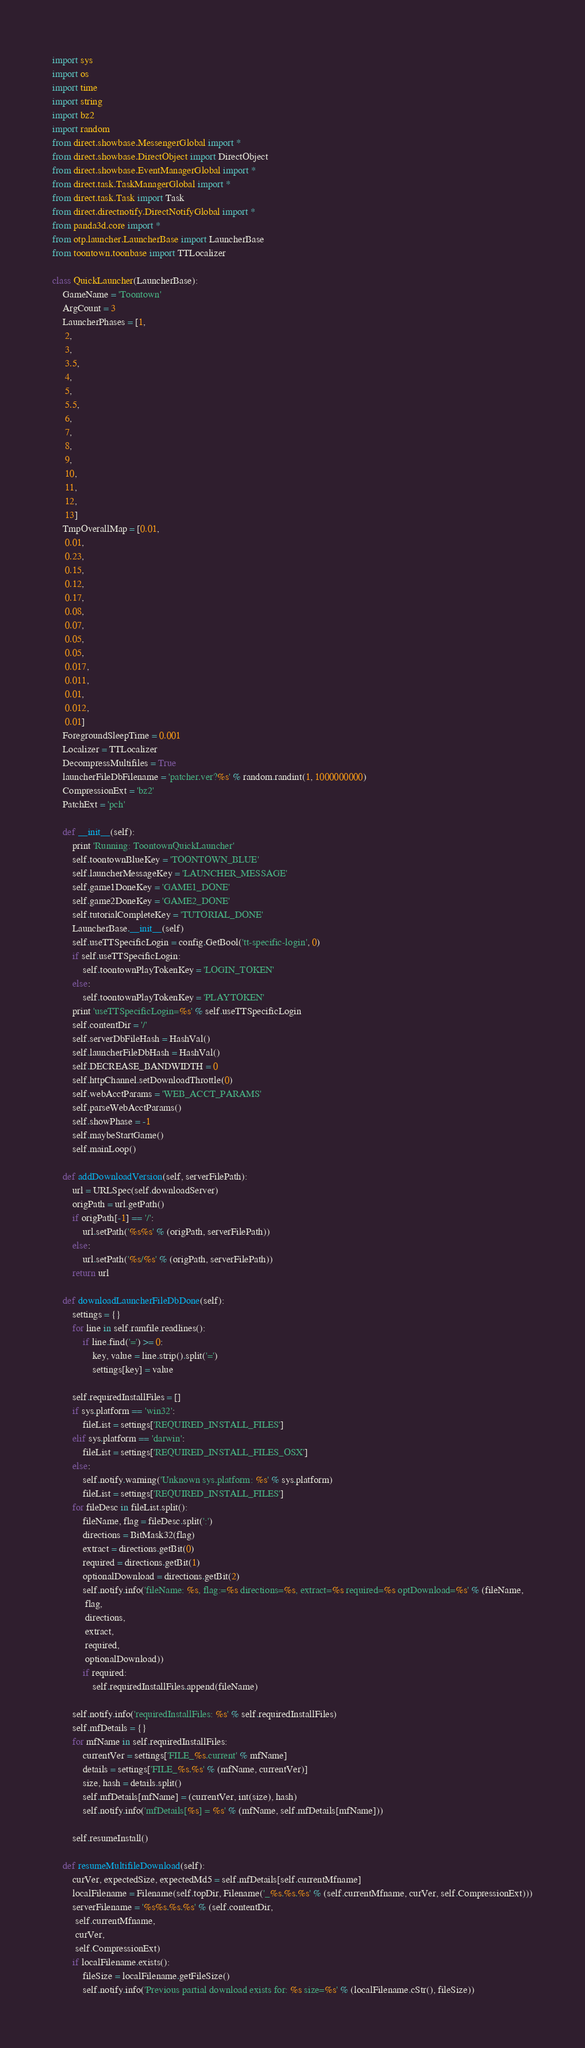Convert code to text. <code><loc_0><loc_0><loc_500><loc_500><_Python_>import sys
import os
import time
import string
import bz2
import random
from direct.showbase.MessengerGlobal import *
from direct.showbase.DirectObject import DirectObject
from direct.showbase.EventManagerGlobal import *
from direct.task.TaskManagerGlobal import *
from direct.task.Task import Task
from direct.directnotify.DirectNotifyGlobal import *
from panda3d.core import *
from otp.launcher.LauncherBase import LauncherBase
from toontown.toonbase import TTLocalizer

class QuickLauncher(LauncherBase):
    GameName = 'Toontown'
    ArgCount = 3
    LauncherPhases = [1,
     2,
     3,
     3.5,
     4,
     5,
     5.5,
     6,
     7,
     8,
     9,
     10,
     11,
     12,
     13]
    TmpOverallMap = [0.01,
     0.01,
     0.23,
     0.15,
     0.12,
     0.17,
     0.08,
     0.07,
     0.05,
     0.05,
     0.017,
     0.011,
     0.01,
     0.012,
     0.01]
    ForegroundSleepTime = 0.001
    Localizer = TTLocalizer
    DecompressMultifiles = True
    launcherFileDbFilename = 'patcher.ver?%s' % random.randint(1, 1000000000)
    CompressionExt = 'bz2'
    PatchExt = 'pch'

    def __init__(self):
        print 'Running: ToontownQuickLauncher'
        self.toontownBlueKey = 'TOONTOWN_BLUE'
        self.launcherMessageKey = 'LAUNCHER_MESSAGE'
        self.game1DoneKey = 'GAME1_DONE'
        self.game2DoneKey = 'GAME2_DONE'
        self.tutorialCompleteKey = 'TUTORIAL_DONE'
        LauncherBase.__init__(self)
        self.useTTSpecificLogin = config.GetBool('tt-specific-login', 0)
        if self.useTTSpecificLogin:
            self.toontownPlayTokenKey = 'LOGIN_TOKEN'
        else:
            self.toontownPlayTokenKey = 'PLAYTOKEN'
        print 'useTTSpecificLogin=%s' % self.useTTSpecificLogin
        self.contentDir = '/'
        self.serverDbFileHash = HashVal()
        self.launcherFileDbHash = HashVal()
        self.DECREASE_BANDWIDTH = 0
        self.httpChannel.setDownloadThrottle(0)
        self.webAcctParams = 'WEB_ACCT_PARAMS'
        self.parseWebAcctParams()
        self.showPhase = -1
        self.maybeStartGame()
        self.mainLoop()

    def addDownloadVersion(self, serverFilePath):
        url = URLSpec(self.downloadServer)
        origPath = url.getPath()
        if origPath[-1] == '/':
            url.setPath('%s%s' % (origPath, serverFilePath))
        else:
            url.setPath('%s/%s' % (origPath, serverFilePath))
        return url

    def downloadLauncherFileDbDone(self):
        settings = {}
        for line in self.ramfile.readlines():
            if line.find('=') >= 0:
                key, value = line.strip().split('=')
                settings[key] = value

        self.requiredInstallFiles = []
        if sys.platform == 'win32':
            fileList = settings['REQUIRED_INSTALL_FILES']
        elif sys.platform == 'darwin':
            fileList = settings['REQUIRED_INSTALL_FILES_OSX']
        else:
            self.notify.warning('Unknown sys.platform: %s' % sys.platform)
            fileList = settings['REQUIRED_INSTALL_FILES']
        for fileDesc in fileList.split():
            fileName, flag = fileDesc.split(':')
            directions = BitMask32(flag)
            extract = directions.getBit(0)
            required = directions.getBit(1)
            optionalDownload = directions.getBit(2)
            self.notify.info('fileName: %s, flag:=%s directions=%s, extract=%s required=%s optDownload=%s' % (fileName,
             flag,
             directions,
             extract,
             required,
             optionalDownload))
            if required:
                self.requiredInstallFiles.append(fileName)

        self.notify.info('requiredInstallFiles: %s' % self.requiredInstallFiles)
        self.mfDetails = {}
        for mfName in self.requiredInstallFiles:
            currentVer = settings['FILE_%s.current' % mfName]
            details = settings['FILE_%s.%s' % (mfName, currentVer)]
            size, hash = details.split()
            self.mfDetails[mfName] = (currentVer, int(size), hash)
            self.notify.info('mfDetails[%s] = %s' % (mfName, self.mfDetails[mfName]))

        self.resumeInstall()

    def resumeMultifileDownload(self):
        curVer, expectedSize, expectedMd5 = self.mfDetails[self.currentMfname]
        localFilename = Filename(self.topDir, Filename('_%s.%s.%s' % (self.currentMfname, curVer, self.CompressionExt)))
        serverFilename = '%s%s.%s.%s' % (self.contentDir,
         self.currentMfname,
         curVer,
         self.CompressionExt)
        if localFilename.exists():
            fileSize = localFilename.getFileSize()
            self.notify.info('Previous partial download exists for: %s size=%s' % (localFilename.cStr(), fileSize))</code> 